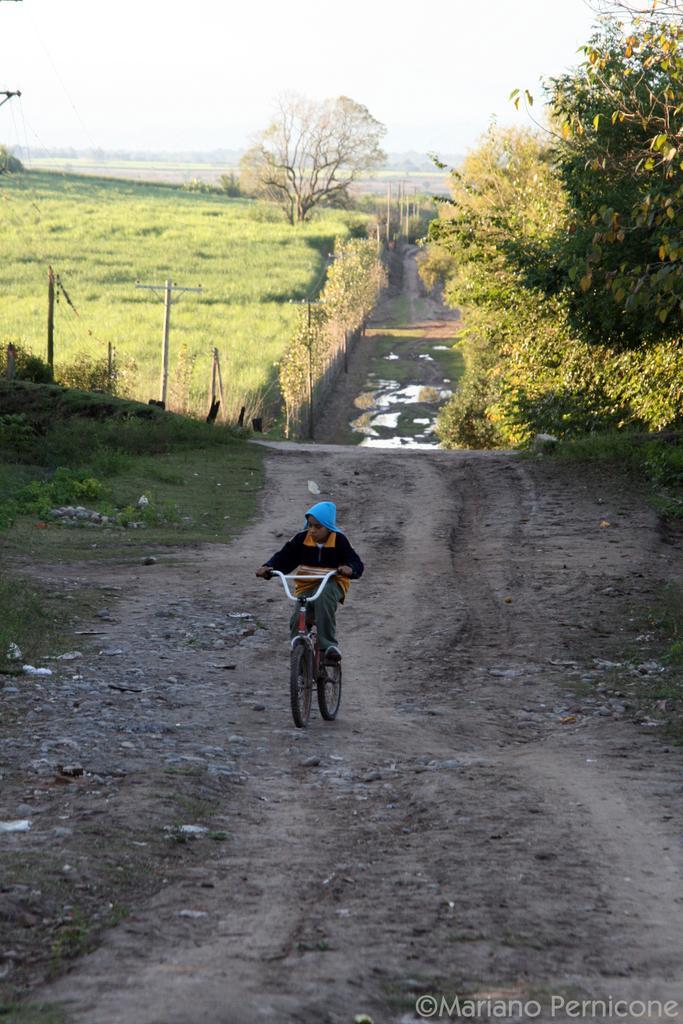In one or two sentences, can you explain what this image depicts? In the middle of the image a boy is riding a bicycle. Behind him there is grass and trees and fencing. At the top of the image there is sky. 